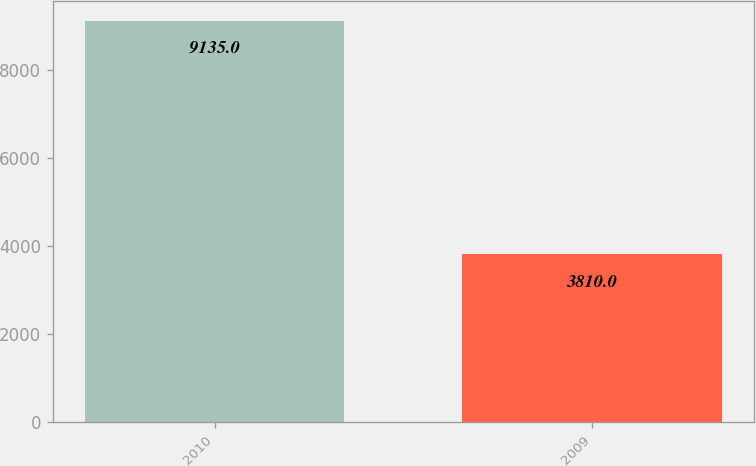Convert chart to OTSL. <chart><loc_0><loc_0><loc_500><loc_500><bar_chart><fcel>2010<fcel>2009<nl><fcel>9135<fcel>3810<nl></chart> 